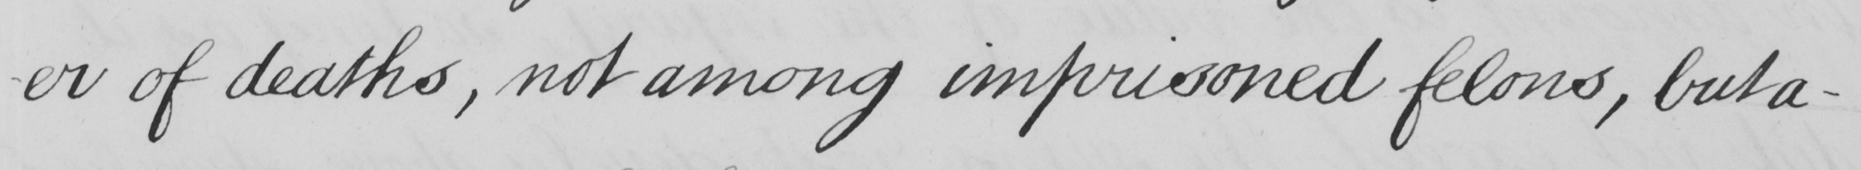Please provide the text content of this handwritten line. -er of deaths , not among imprisoned felons , but a- 